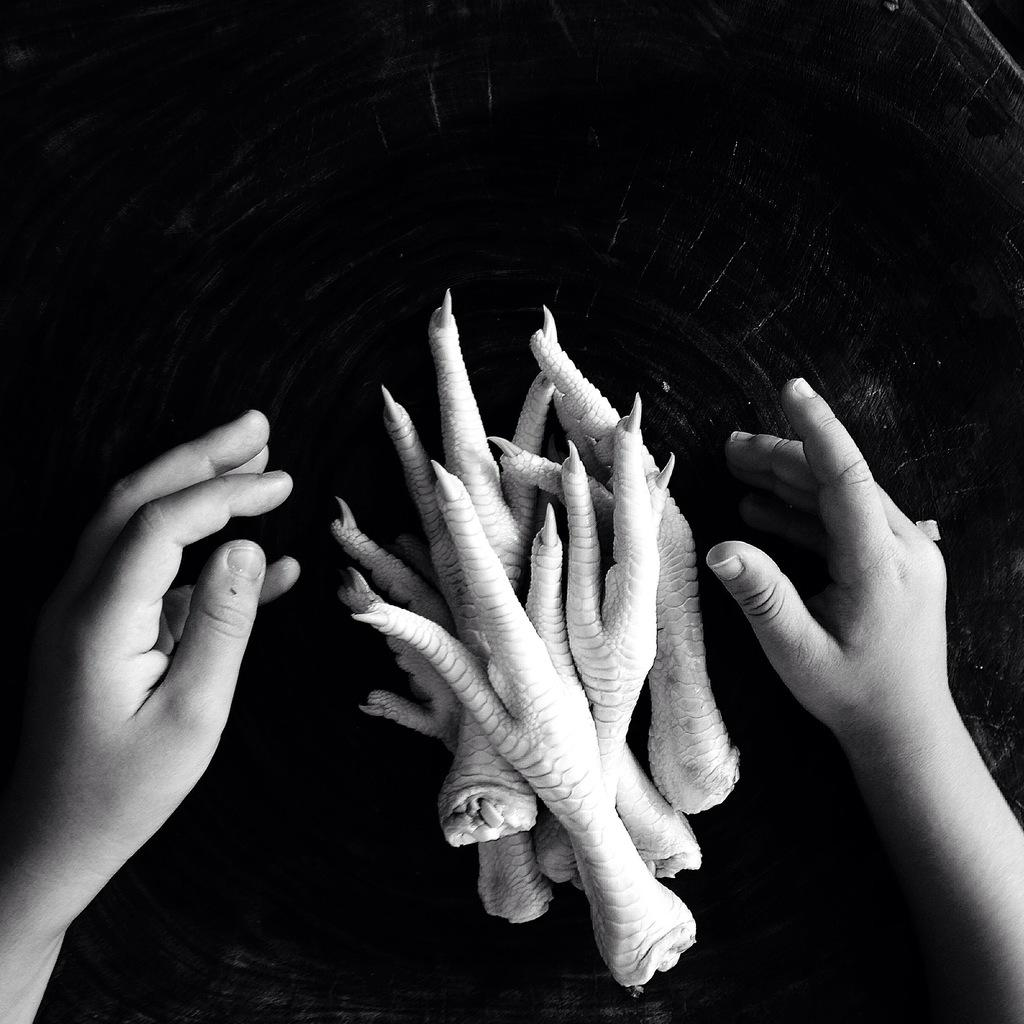What is the color scheme of the image? The image is black and white. What can be seen in the image related to a hen? There are claws of a hen in the image. What else is present in the image related to a person? There are hands of a person in the image. What is the background or surface on which the claws and hands are placed? The claws and hands are placed on a black surface. What type of rail can be seen in the image? There is no rail present in the image. How much milk is being poured by the person in the image? There is no milk or pouring action depicted in the image. 